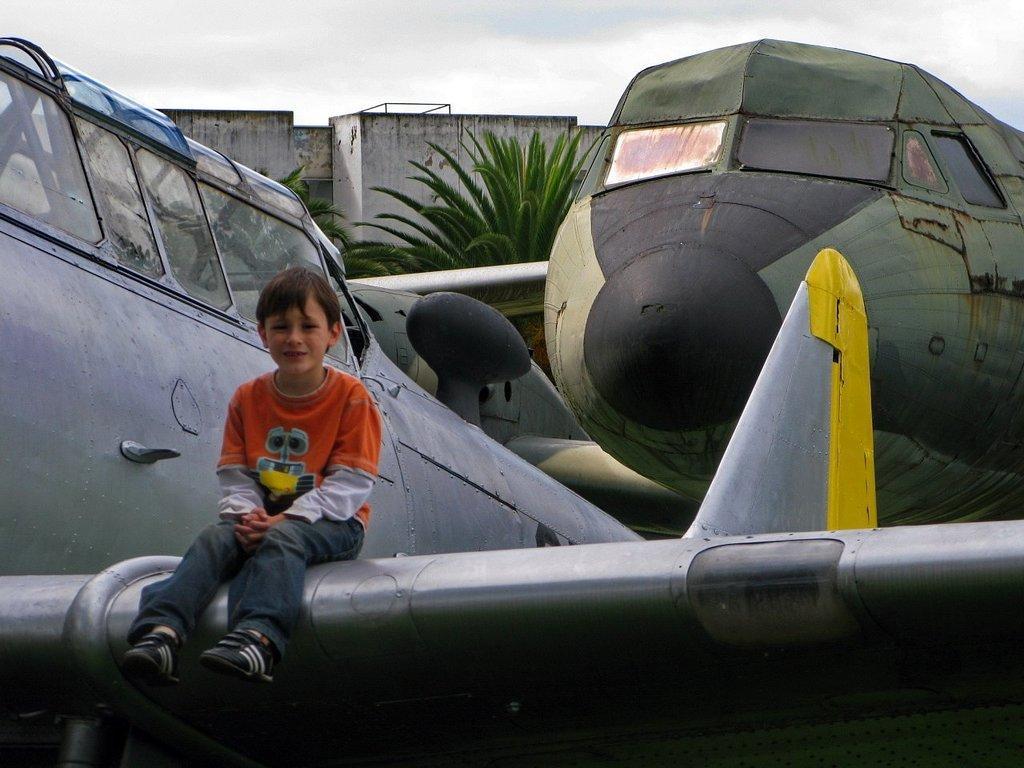Describe this image in one or two sentences. In this image we can see few model aircrafts. There are few trees in the image. There is a sky in the image. There is a house in the image. A boy is sitting on the model aircraft. 